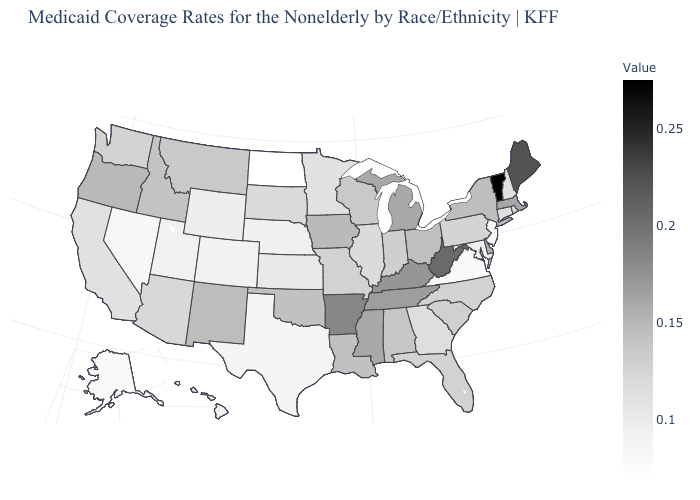Among the states that border Nevada , does Utah have the lowest value?
Keep it brief. Yes. Which states have the lowest value in the MidWest?
Concise answer only. North Dakota. Among the states that border Ohio , does Michigan have the highest value?
Concise answer only. No. Which states have the highest value in the USA?
Be succinct. Vermont. 